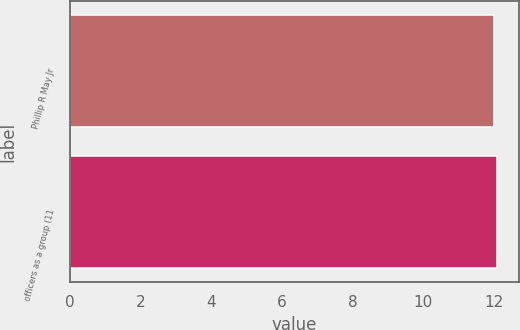Convert chart to OTSL. <chart><loc_0><loc_0><loc_500><loc_500><bar_chart><fcel>Phillip R May Jr<fcel>officers as a group (11<nl><fcel>12<fcel>12.1<nl></chart> 